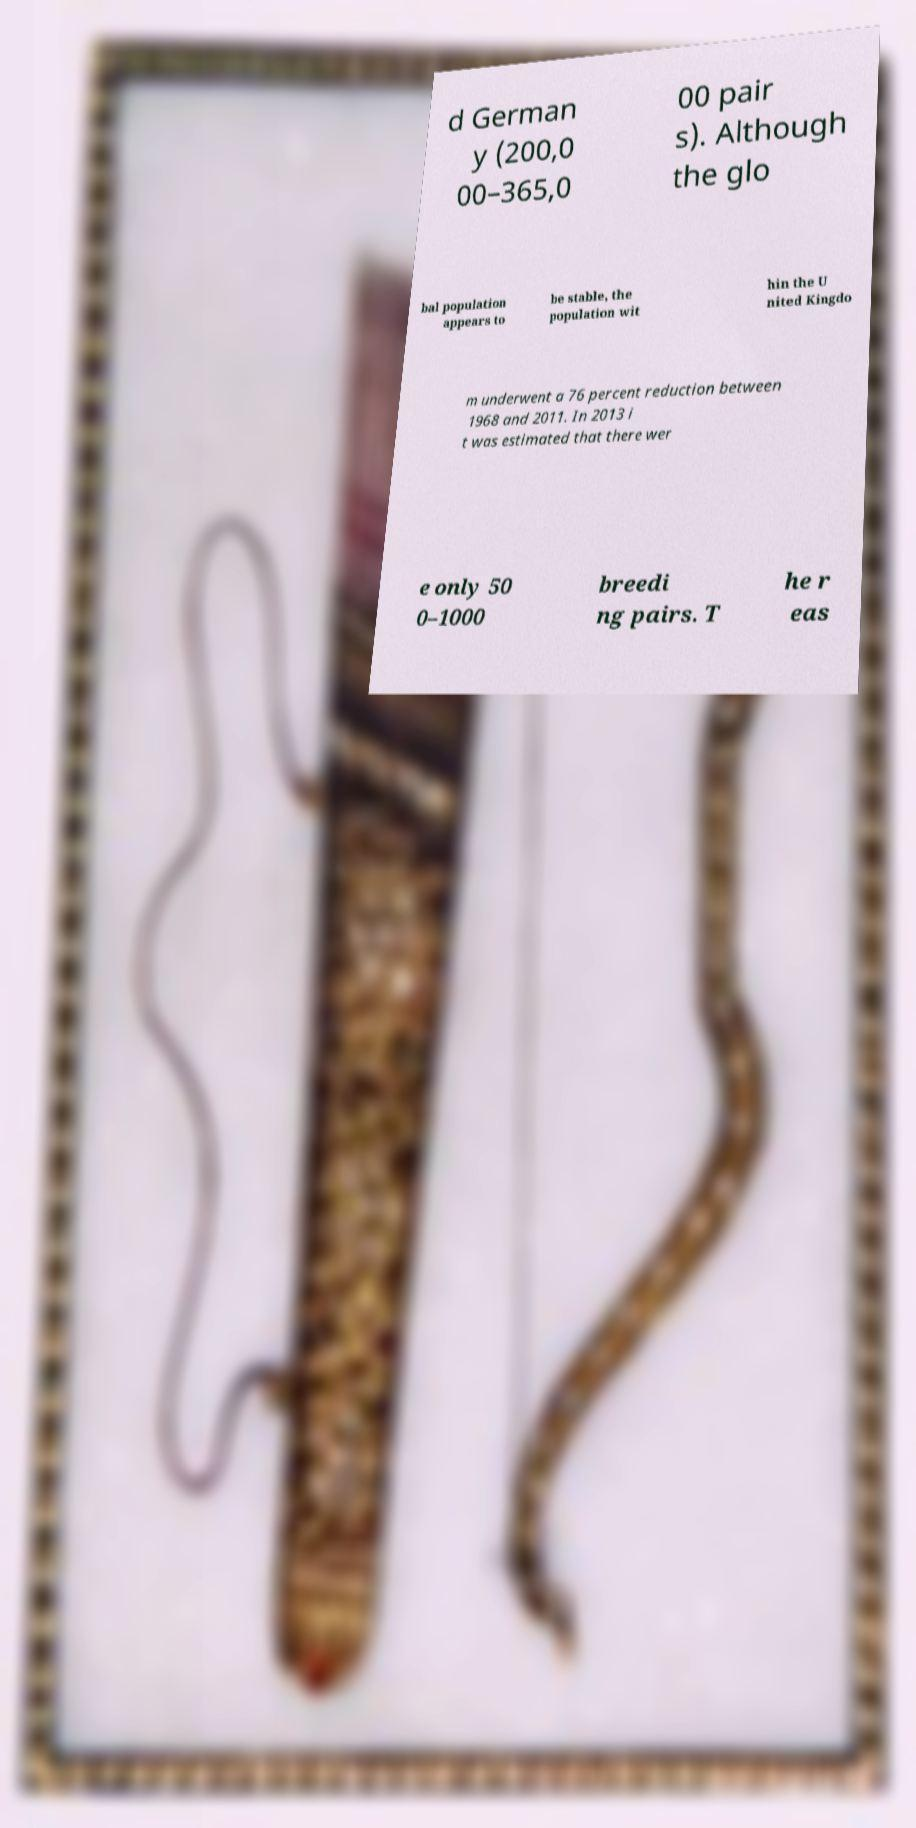What messages or text are displayed in this image? I need them in a readable, typed format. d German y (200,0 00–365,0 00 pair s). Although the glo bal population appears to be stable, the population wit hin the U nited Kingdo m underwent a 76 percent reduction between 1968 and 2011. In 2013 i t was estimated that there wer e only 50 0–1000 breedi ng pairs. T he r eas 